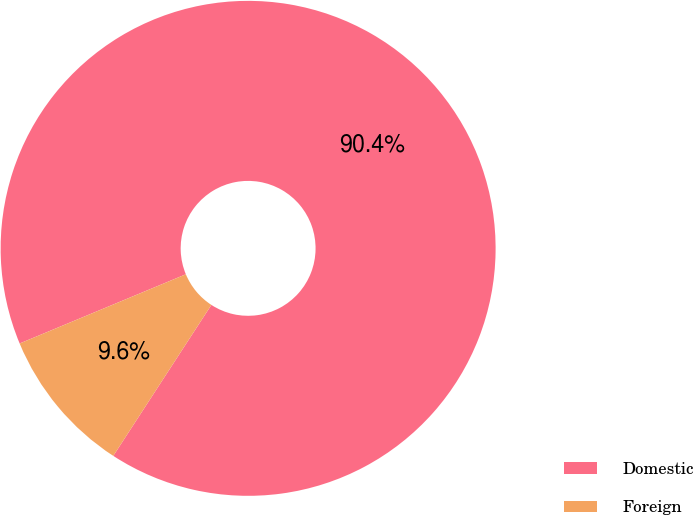Convert chart. <chart><loc_0><loc_0><loc_500><loc_500><pie_chart><fcel>Domestic<fcel>Foreign<nl><fcel>90.45%<fcel>9.55%<nl></chart> 